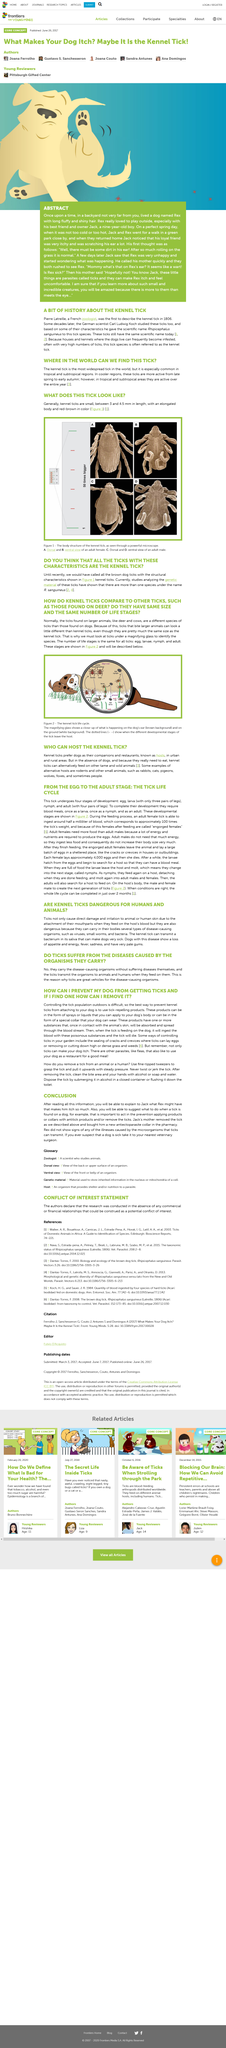Identify some key points in this picture. According to the article, it is recommended to dispose of a tick by submerging it in alcohol. The entire tick life cycle can be completed in just over two months if conditions are favorable. The article highlights tick-repelling products that are available in the form of a collar that your dog can wear. Yes, kennel ticks and ticks that infest larger animals like cows are the same size. There are four stages of development in the tick life cycle. 